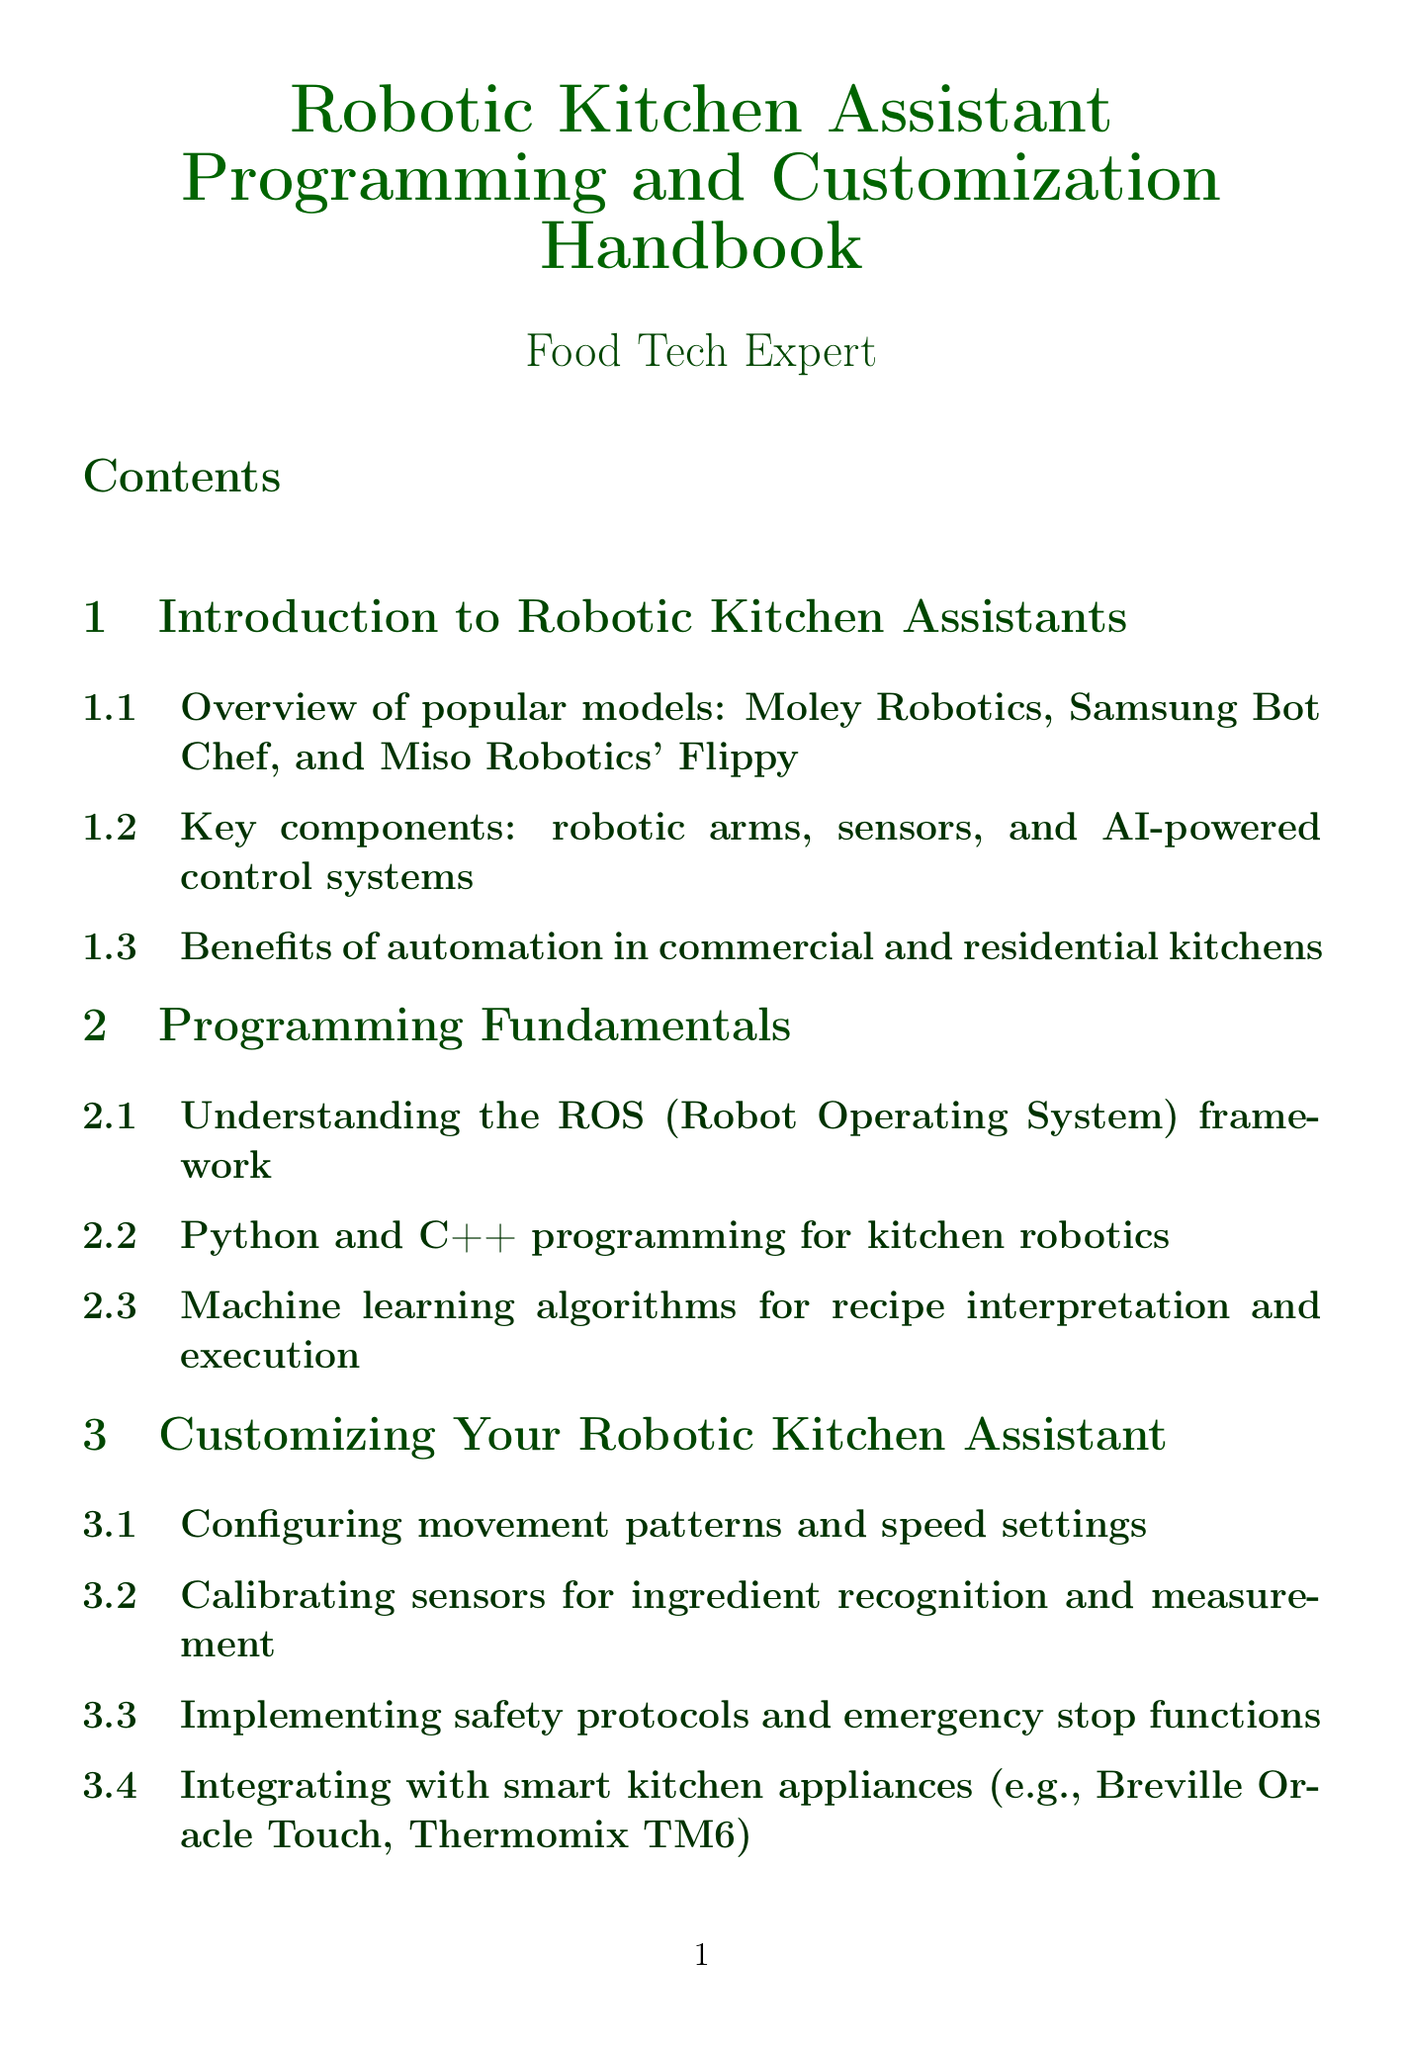What are some popular robotic kitchen assistant models? The document lists popular models such as Moley Robotics, Samsung Bot Chef, and Miso Robotics' Flippy.
Answer: Moley Robotics, Samsung Bot Chef, Miso Robotics' Flippy Which programming languages are mentioned for kitchen robotics? The programming fundamentals section references Python and C++ as the programming languages used.
Answer: Python, C++ What is a key benefit of kitchen automation highlighted in the document? The benefits section indicates improved efficiency and consistency in food preparation as key advantages of automation.
Answer: Efficiency What is one method for recognizing ingredients mentioned in the customization section? The document discusses calibrating sensors for ingredient recognition and measurement.
Answer: Calibrating sensors Which API is integrated for recipe database management? The recipe database management section mentions integrating with popular recipe APIs such as Spoonacular and Edamam.
Answer: Spoonacular, Edamam What year is mentioned in regulations for robotic safety standards? The document refers to the ANSI/RIA R15.06-2012 as a regulation concerning industrial robots and safety requirements.
Answer: 2012 What technology is used for voice control in advanced features? The advanced features section indicates that natural language processing is used for implementing voice control.
Answer: Natural language processing How are recipes structured according to the document? The recipe database management section states that recipes can be created in structured formats like JSON or XML.
Answer: JSON, XML 